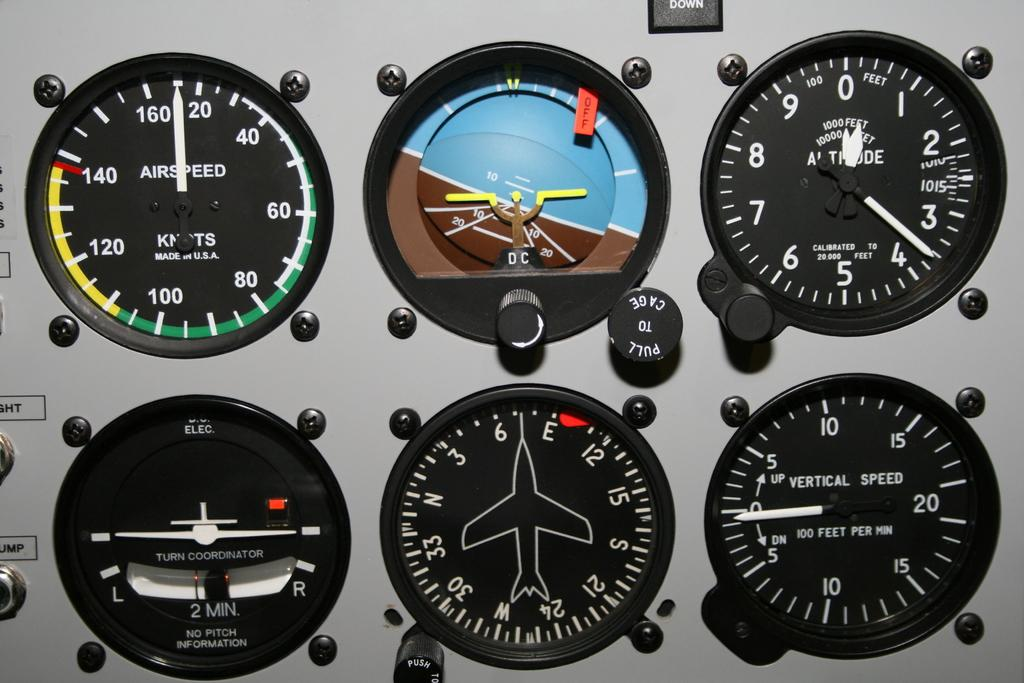<image>
Render a clear and concise summary of the photo. Among the readouts is one for vertical speed. 